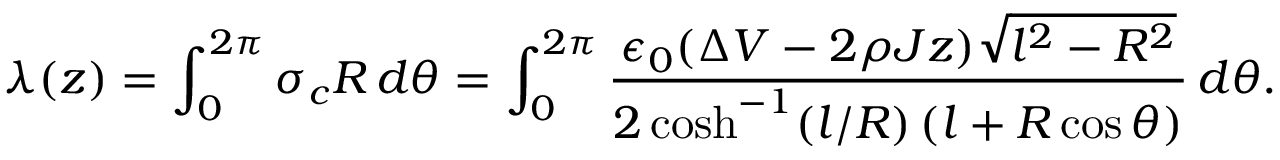Convert formula to latex. <formula><loc_0><loc_0><loc_500><loc_500>\lambda ( z ) = \int _ { 0 } ^ { 2 \pi } \sigma _ { c } R \, d \theta = \int _ { 0 } ^ { 2 \pi } \frac { \epsilon _ { 0 } ( \Delta V - 2 \rho J z ) \sqrt { l ^ { 2 } - R ^ { 2 } } } { 2 \cosh ^ { - 1 } ( l / R ) \, ( l + R \cos \theta ) } \, d \theta .</formula> 